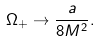Convert formula to latex. <formula><loc_0><loc_0><loc_500><loc_500>\Omega _ { + } \rightarrow \frac { a } { 8 M ^ { 2 } } .</formula> 